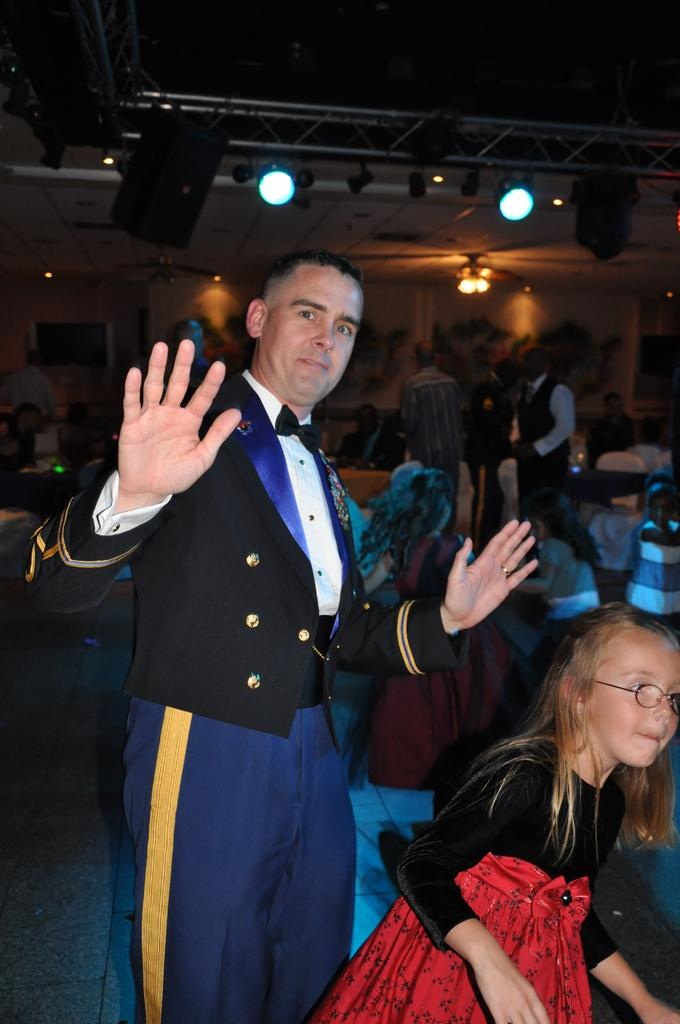What is the man in the image doing with his hands? The man is raising his hands in the image. Who is the man looking at in the image? The man is looking at someone in the image. Can you describe the little girl in the image? There is a little girl in the image. What can be seen in the background of the image? There are other people in the background of the image. What type of education does the man in the image have? There is no information about the man's education in the image. How many snakes are present in the image? There are no snakes present in the image. 